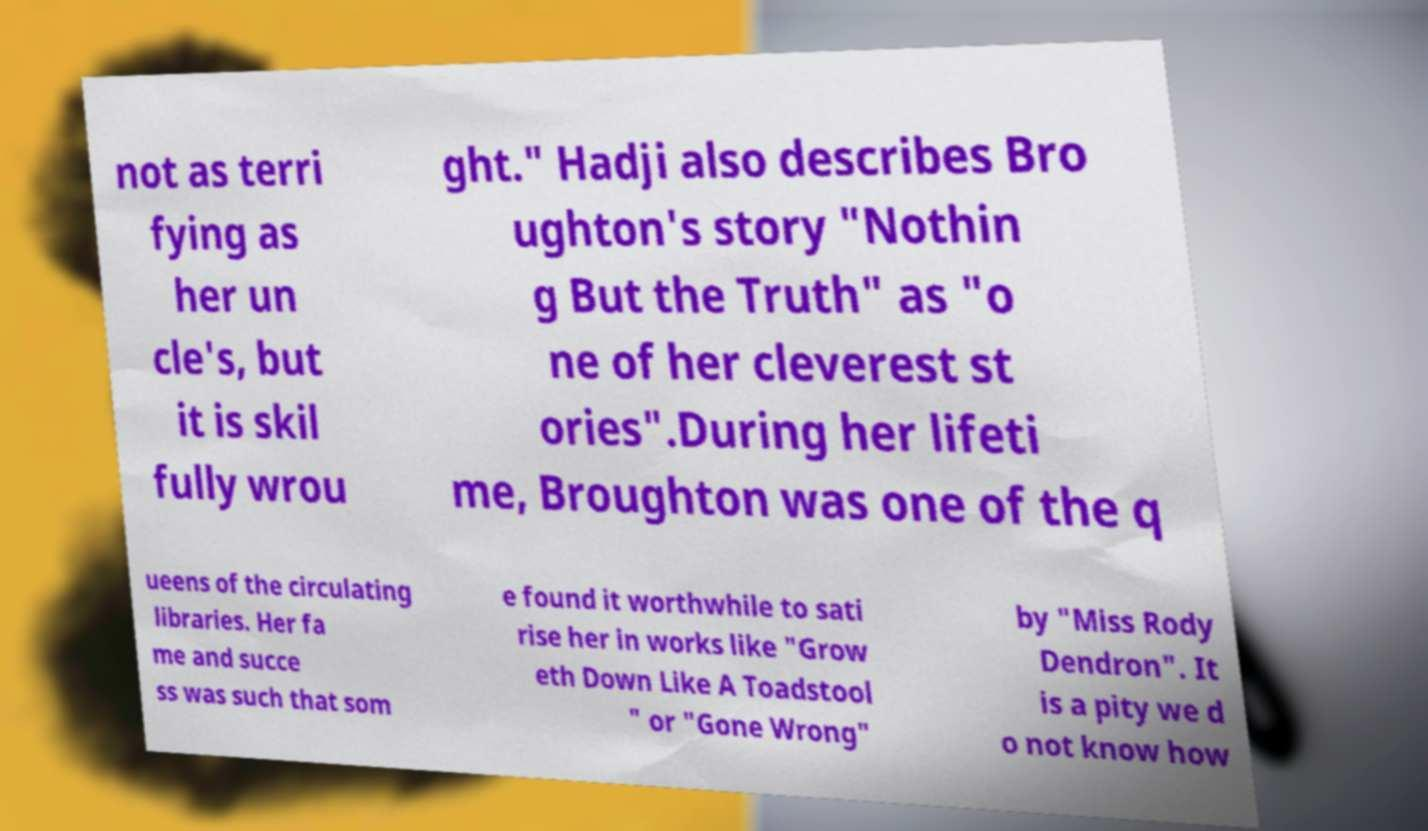I need the written content from this picture converted into text. Can you do that? not as terri fying as her un cle's, but it is skil fully wrou ght." Hadji also describes Bro ughton's story "Nothin g But the Truth" as "o ne of her cleverest st ories".During her lifeti me, Broughton was one of the q ueens of the circulating libraries. Her fa me and succe ss was such that som e found it worthwhile to sati rise her in works like "Grow eth Down Like A Toadstool " or "Gone Wrong" by "Miss Rody Dendron". It is a pity we d o not know how 